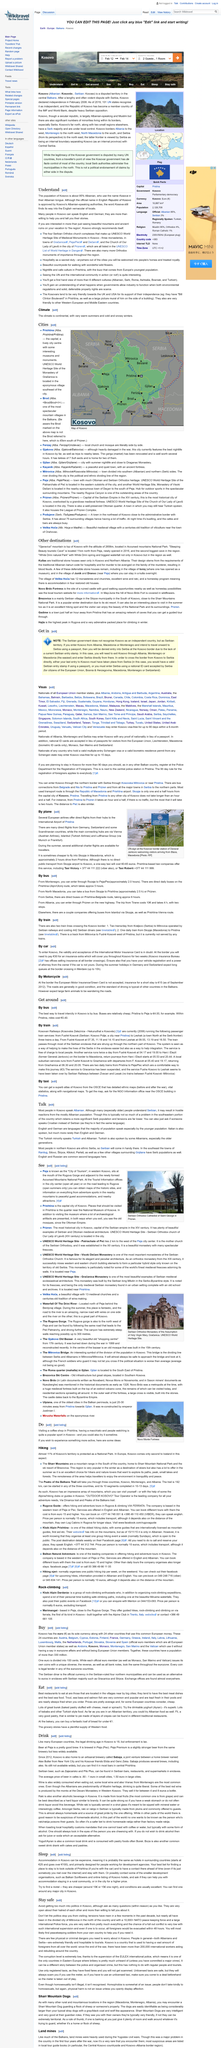Draw attention to some important aspects in this diagram. The Seberian Orthodox Monastery is a picture of spirituality and devotion. The majority of the population speaks English and German, in addition to the primary language spoken. European airlines offer direct flights from their hubs to the Pristina International Airport. The cheaper option is to travel to Kosovo by train rather than by car, as the cost of the train ticket is significantly lower than the cost of car insurance. It is estimated that the train ticket costs only a few euros, while the insurance for the car would cost at least €30. Therefore, it is clear that the train is the more economical choice for travel to Kosovo. It is a well-known fact that people in general, regardless of their ethnic background, are known for their friendly and hospitable nature towards tourists. 